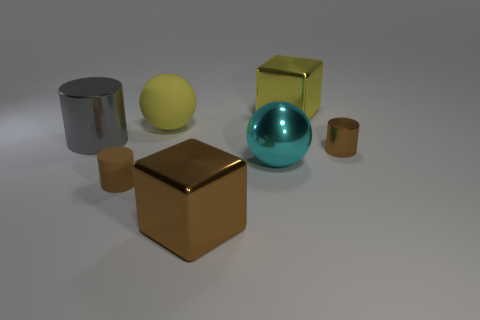Subtract all small brown metal cylinders. How many cylinders are left? 2 Subtract all gray cubes. How many brown cylinders are left? 2 Subtract 1 cylinders. How many cylinders are left? 2 Add 2 gray metallic cylinders. How many objects exist? 9 Subtract all cylinders. How many objects are left? 4 Subtract all small objects. Subtract all matte spheres. How many objects are left? 4 Add 3 big cyan metallic objects. How many big cyan metallic objects are left? 4 Add 5 big metallic blocks. How many big metallic blocks exist? 7 Subtract 1 cyan balls. How many objects are left? 6 Subtract all yellow cylinders. Subtract all cyan spheres. How many cylinders are left? 3 